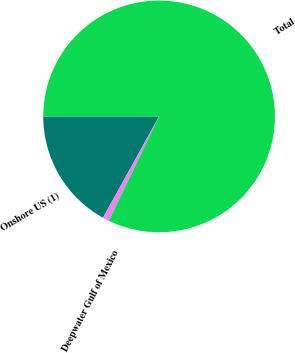Convert chart to OTSL. <chart><loc_0><loc_0><loc_500><loc_500><pie_chart><fcel>Onshore US (1)<fcel>Deepwater Gulf of Mexico<fcel>Total<nl><fcel>16.95%<fcel>0.91%<fcel>82.14%<nl></chart> 